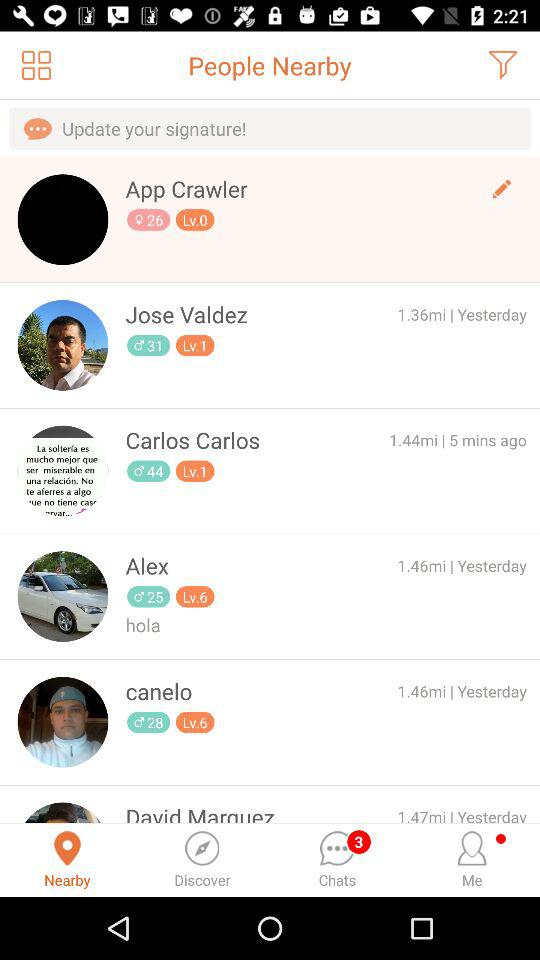How many chats are unread? There are 3 unread chats. 